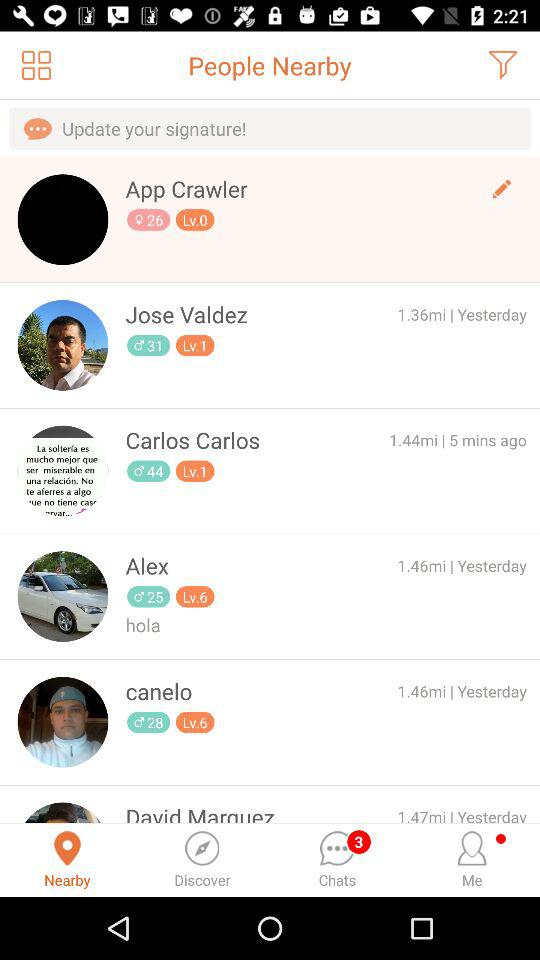How many chats are unread? There are 3 unread chats. 